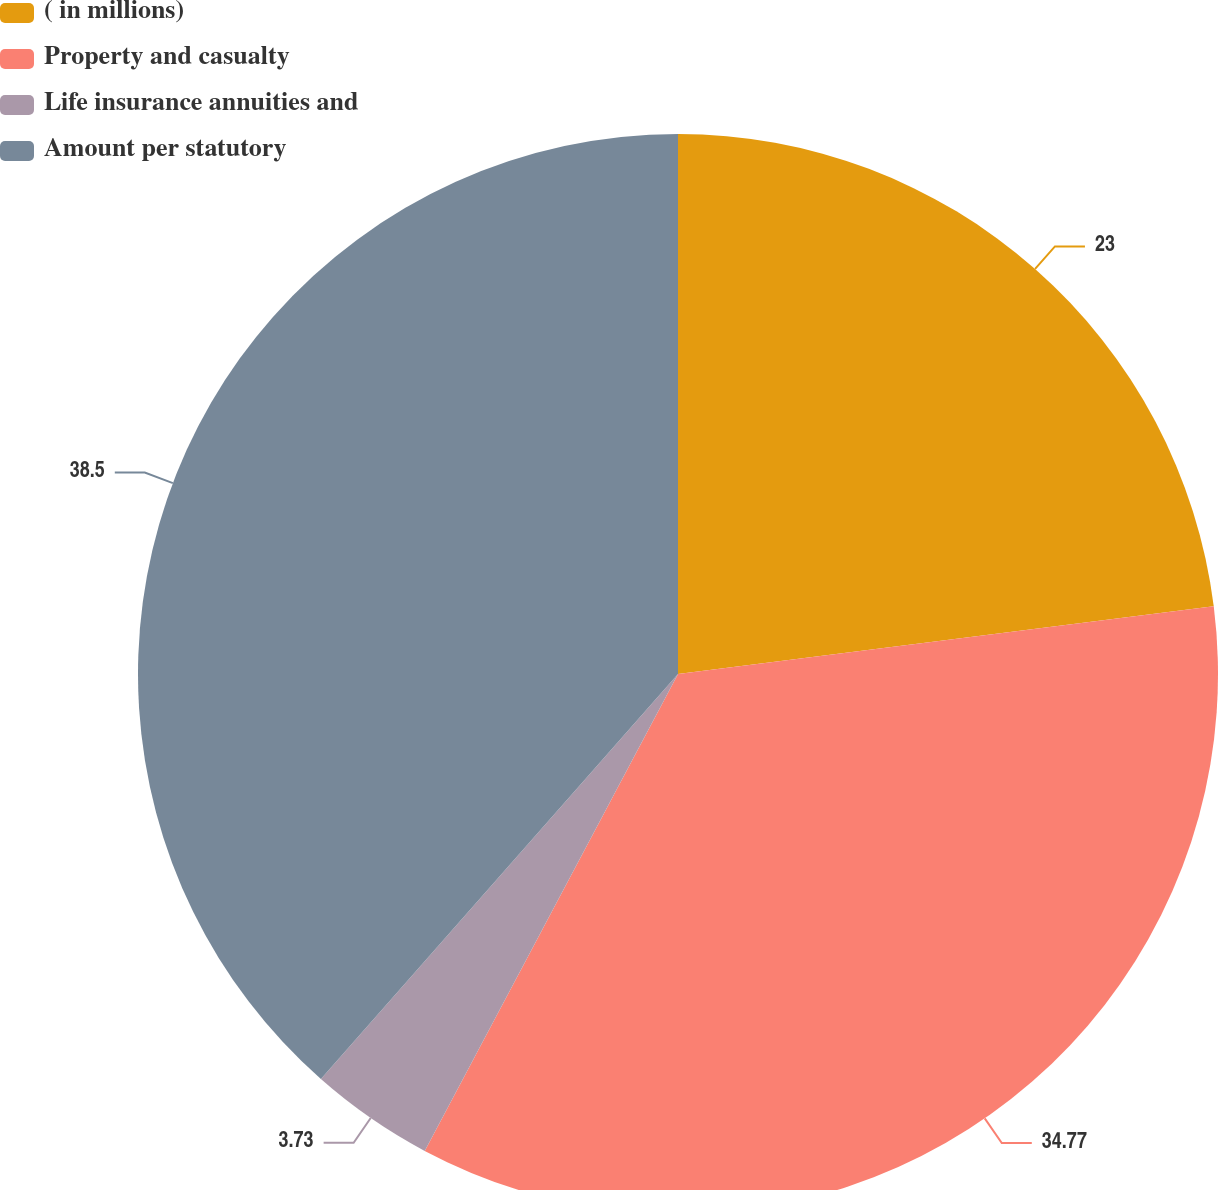Convert chart to OTSL. <chart><loc_0><loc_0><loc_500><loc_500><pie_chart><fcel>( in millions)<fcel>Property and casualty<fcel>Life insurance annuities and<fcel>Amount per statutory<nl><fcel>23.0%<fcel>34.77%<fcel>3.73%<fcel>38.5%<nl></chart> 